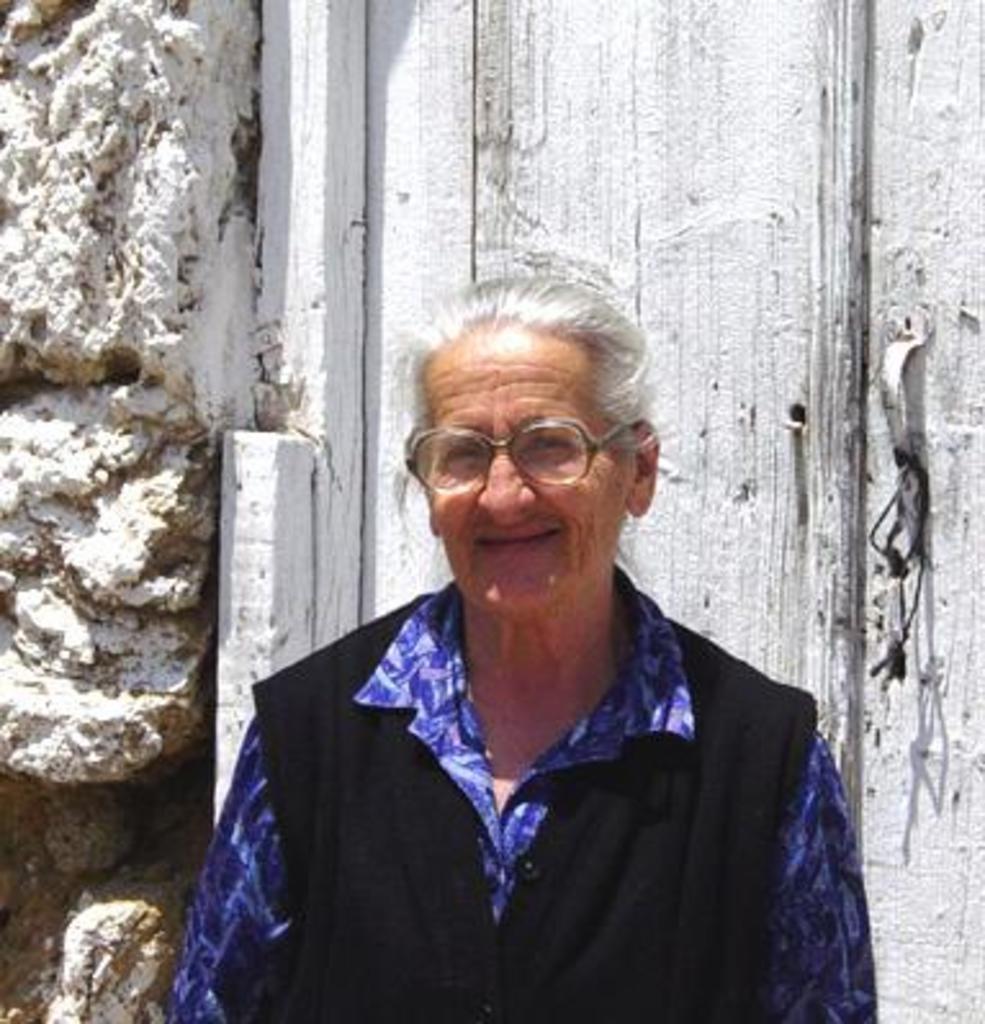Please provide a concise description of this image. In this image I can see a person is wearing blue and black color dress. Back I can see a rock and wooden object and it is in white color. 